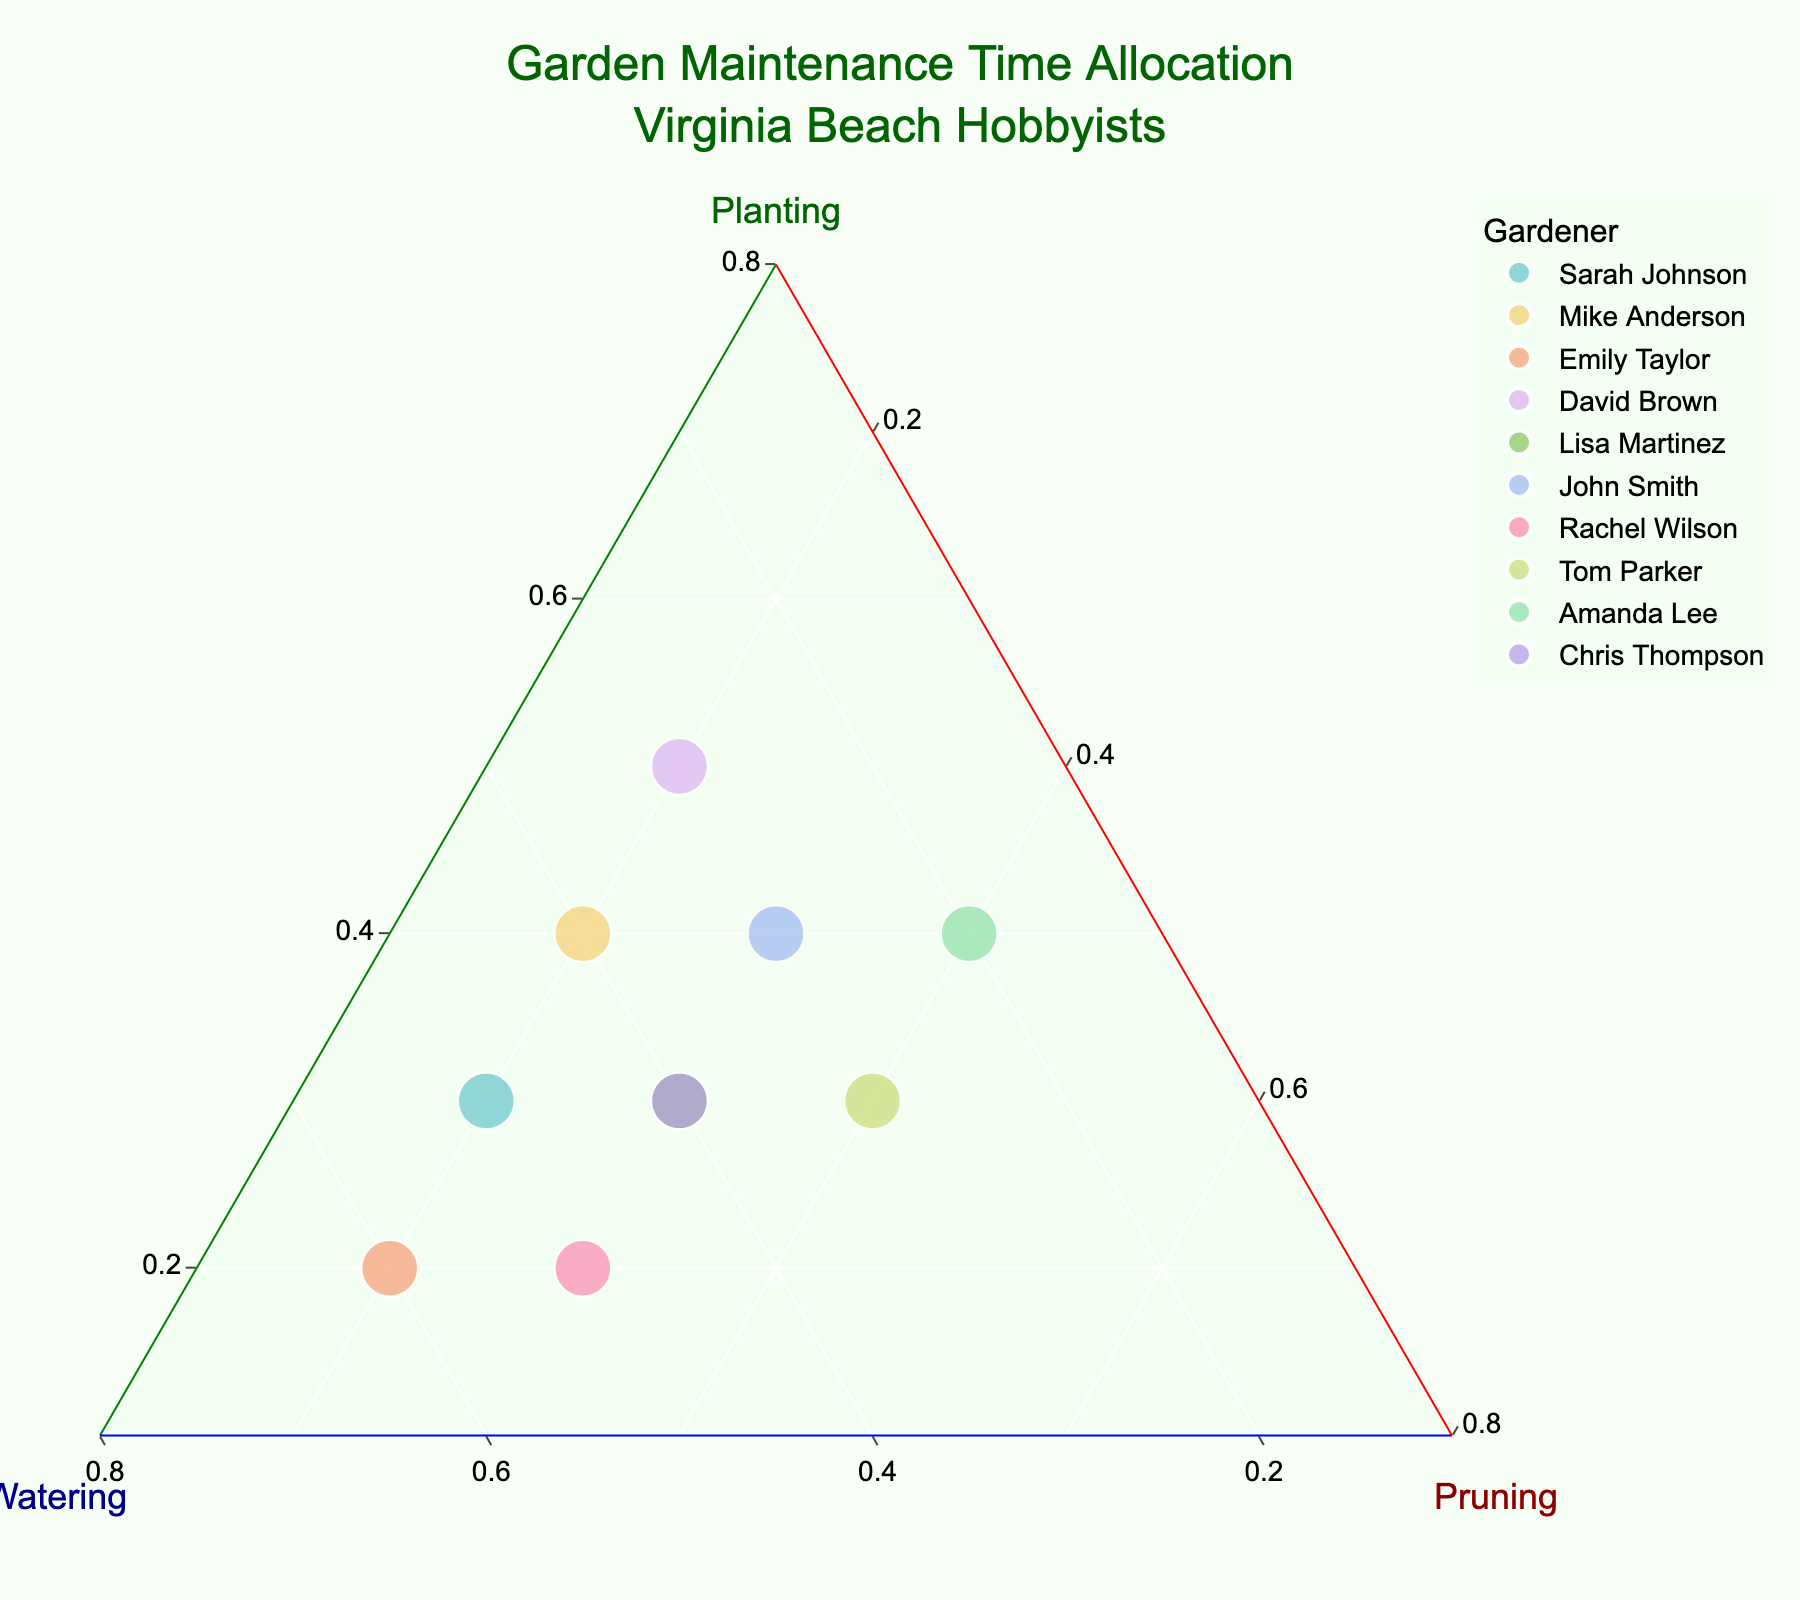What is the title of the figure? The title is located at the top center of the figure, in a larger font. It reads "Garden Maintenance Time Allocation<br>Virginia Beach Hobbyists".
Answer: Garden Maintenance Time Allocation<br>Virginia Beach Hobbyists How many gardeners have equal proportions of time spent on planting and watering? The figure shows a ternary plot where the proportions for planting and watering are equal (same position along the 'aaxis' and 'baxis'). Here, Mike Anderson has equal proportions of 0.4 and 0.4 for planting and watering respectively.
Answer: One gardener Which gardener spends the most time pruning the garden? By observing the points furthest along the pruning axis, Amanda Lee, with 0.4 pruning proportion, is at the highest level on the pruning axis.
Answer: Amanda Lee Among Sarah Johnson and Lisa Martinez, who spends more time planting? Compare the values on the planting axis for both gardeners. Sarah Johnson spends 0.3 while Lisa Martinez spends the same 0.3.
Answer: Both spend the same What is the total proportion of planting, watering, and pruning for Emily Taylor and Rachel Wilson together? Add the proportions for each gardener: Emily Taylor (0.2 + 0.6 + 0.2 = 1.0), Rachel Wilson (0.2 + 0.5 + 0.3 = 1.0). Their combined total is 1.0 + 1.0 = 2.0.
Answer: 2.0 Who spends the least time watering? By observing the points with the smallest value on the watering axis (baxis), Amanda Lee has a watering proportion of 0.2, which is the least.
Answer: Amanda Lee Which gardener has the most balanced time allocation across all activities? Look for the point close to the center of the ternary plot indicating near-equal proportions. Tom Parker with proportions (0.3, 0.3, 0.4) is fairly balanced.
Answer: Tom Parker What proportion of gardeners spend less than or equal to 0.3 on pruning? Count the gardeners whose pruning values are less than or equal to 0.3: Sarah Johnson, Mike Anderson, Emily Taylor, David Brown, John Smith, Chris Thompson (6 out of 10).
Answer: 60% How many gardeners spend 0.4 on at least one activity? Identify the points where at least one proportion is 0.4: Mike Anderson, Amanda Lee, John Smith (3 gardeners).
Answer: Three gardeners Comparing the gardeners with the data point in the background image, do any gardeners have significantly different proportions for each activity? Check the positions of data points to verify if any is considerably off from others in the background image. Amanda Lee's point seems to be considerably different due to her higher pruning value and lower in others, making her allocation distinct.
Answer: Amanda Lee 